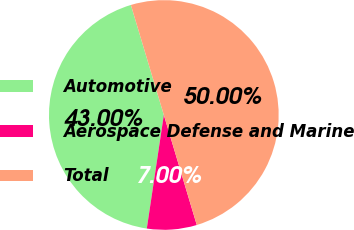Convert chart to OTSL. <chart><loc_0><loc_0><loc_500><loc_500><pie_chart><fcel>Automotive<fcel>Aerospace Defense and Marine<fcel>Total<nl><fcel>43.0%<fcel>7.0%<fcel>50.0%<nl></chart> 